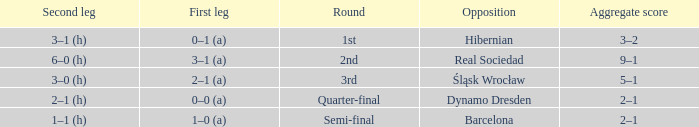Give me the full table as a dictionary. {'header': ['Second leg', 'First leg', 'Round', 'Opposition', 'Aggregate score'], 'rows': [['3–1 (h)', '0–1 (a)', '1st', 'Hibernian', '3–2'], ['6–0 (h)', '3–1 (a)', '2nd', 'Real Sociedad', '9–1'], ['3–0 (h)', '2–1 (a)', '3rd', 'Śląsk Wrocław', '5–1'], ['2–1 (h)', '0–0 (a)', 'Quarter-final', 'Dynamo Dresden', '2–1'], ['1–1 (h)', '1–0 (a)', 'Semi-final', 'Barcelona', '2–1']]} What was the first leg against Hibernian? 0–1 (a). 